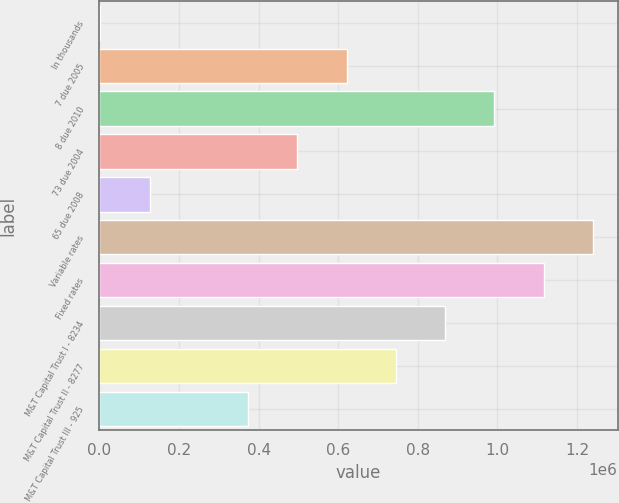Convert chart. <chart><loc_0><loc_0><loc_500><loc_500><bar_chart><fcel>In thousands<fcel>7 due 2005<fcel>8 due 2010<fcel>73 due 2004<fcel>65 due 2008<fcel>Variable rates<fcel>Fixed rates<fcel>M&T Capital Trust I - 8234<fcel>M&T Capital Trust II - 8277<fcel>M&T Capital Trust III - 925<nl><fcel>2001<fcel>621000<fcel>992400<fcel>497201<fcel>125801<fcel>1.24e+06<fcel>1.1162e+06<fcel>868600<fcel>744800<fcel>373401<nl></chart> 